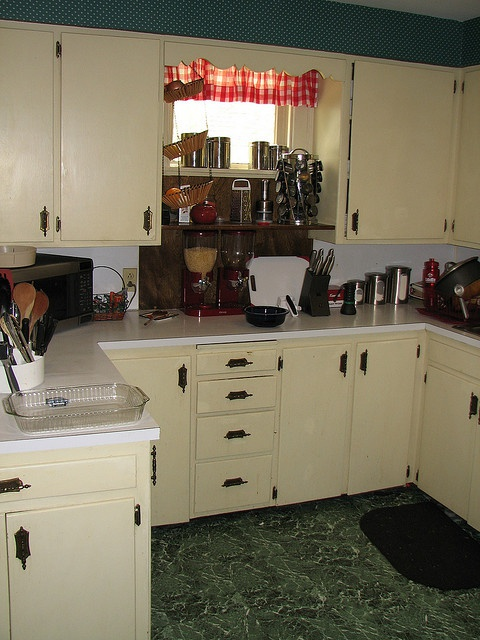Describe the objects in this image and their specific colors. I can see microwave in teal, black, and darkgray tones, bowl in teal, black, gray, and darkgray tones, spoon in teal, maroon, and brown tones, spoon in teal, gray, black, darkgreen, and tan tones, and spoon in teal, maroon, black, and brown tones in this image. 